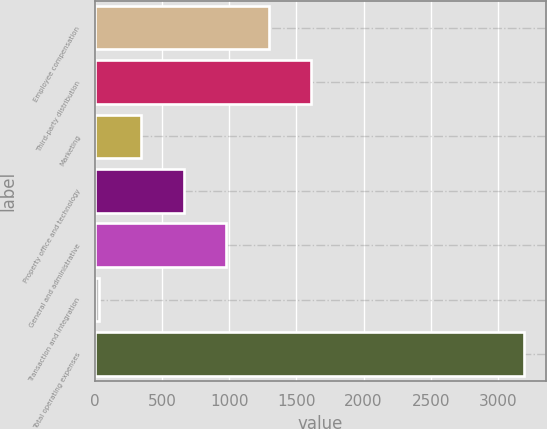Convert chart. <chart><loc_0><loc_0><loc_500><loc_500><bar_chart><fcel>Employee compensation<fcel>Third-party distribution<fcel>Marketing<fcel>Property office and technology<fcel>General and administrative<fcel>Transaction and integration<fcel>Total operating expenses<nl><fcel>1295.28<fcel>1611.75<fcel>345.87<fcel>662.34<fcel>978.81<fcel>29.4<fcel>3194.1<nl></chart> 